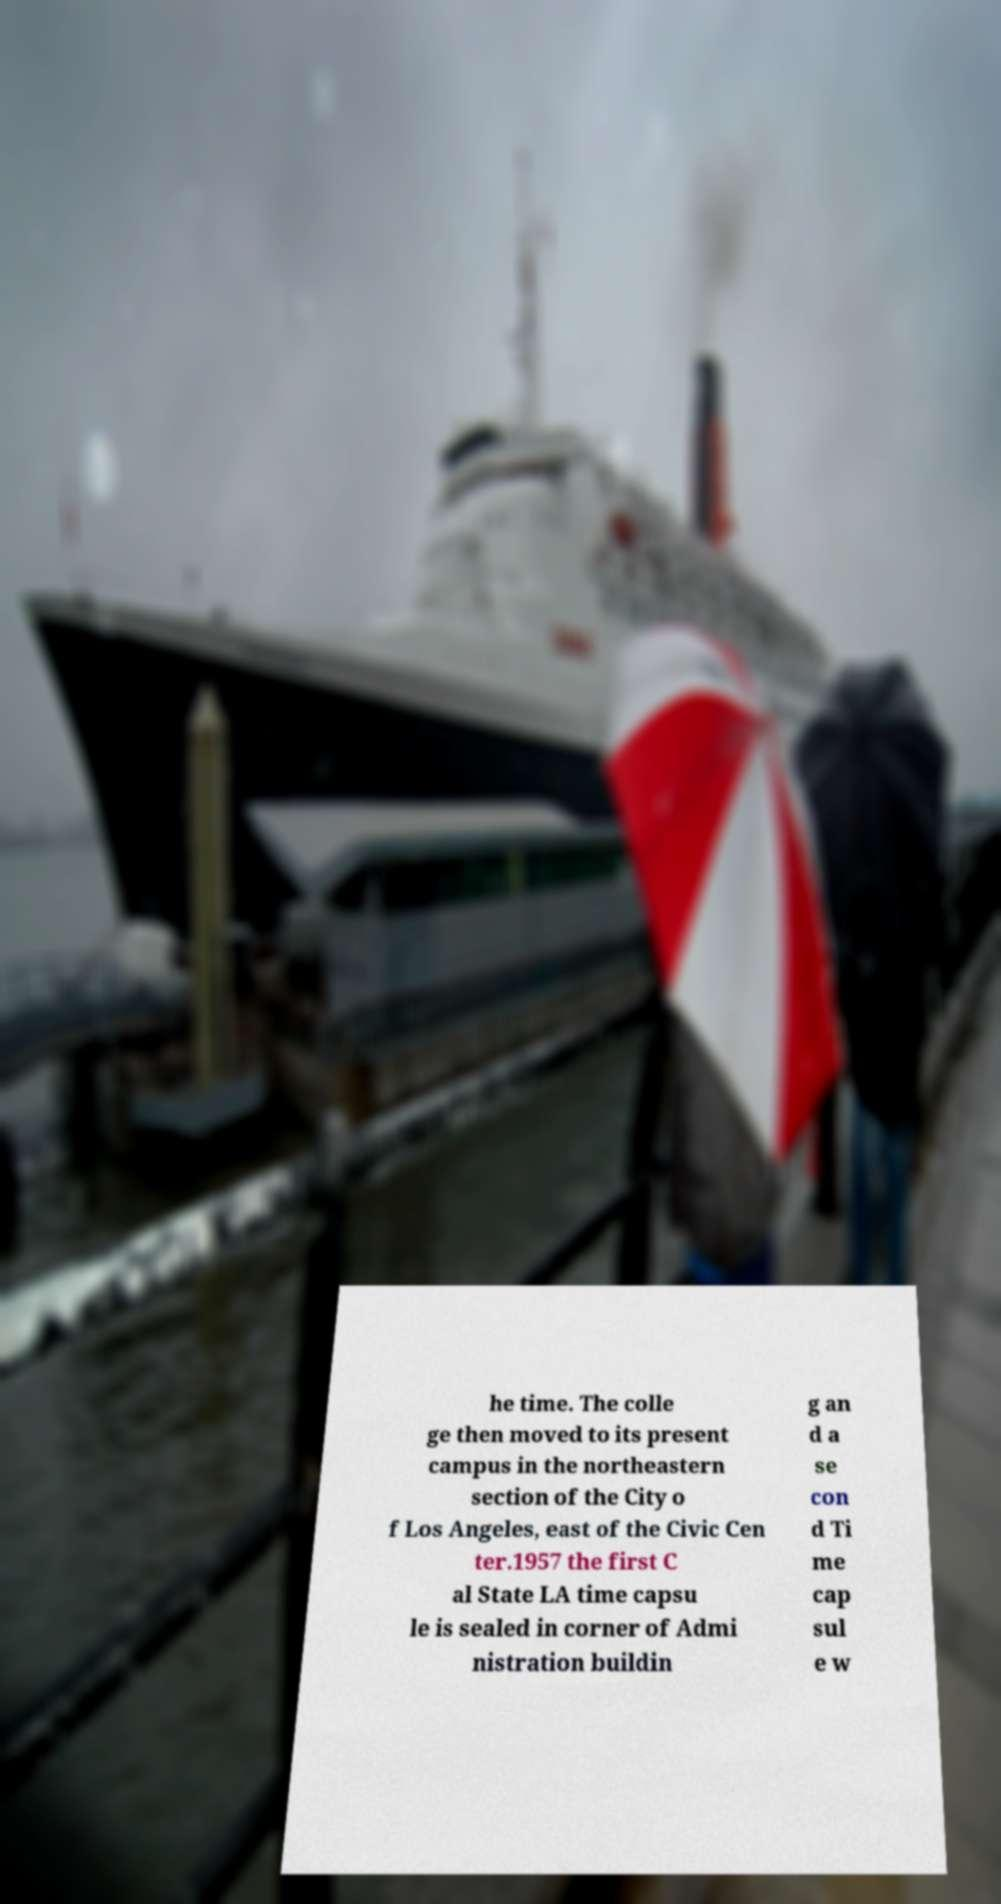Please identify and transcribe the text found in this image. he time. The colle ge then moved to its present campus in the northeastern section of the City o f Los Angeles, east of the Civic Cen ter.1957 the first C al State LA time capsu le is sealed in corner of Admi nistration buildin g an d a se con d Ti me cap sul e w 